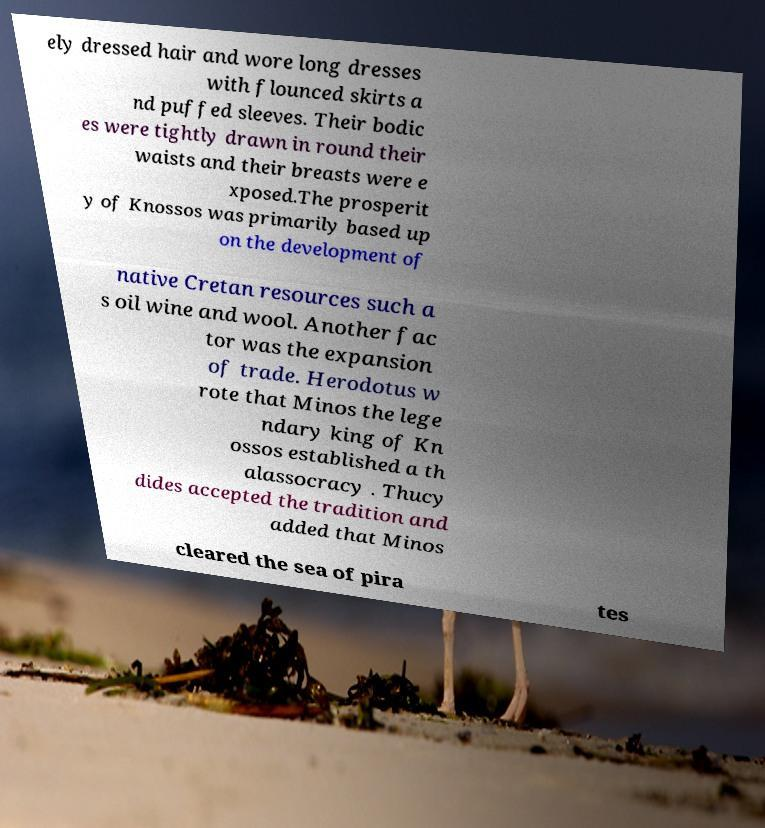Can you read and provide the text displayed in the image?This photo seems to have some interesting text. Can you extract and type it out for me? ely dressed hair and wore long dresses with flounced skirts a nd puffed sleeves. Their bodic es were tightly drawn in round their waists and their breasts were e xposed.The prosperit y of Knossos was primarily based up on the development of native Cretan resources such a s oil wine and wool. Another fac tor was the expansion of trade. Herodotus w rote that Minos the lege ndary king of Kn ossos established a th alassocracy . Thucy dides accepted the tradition and added that Minos cleared the sea of pira tes 